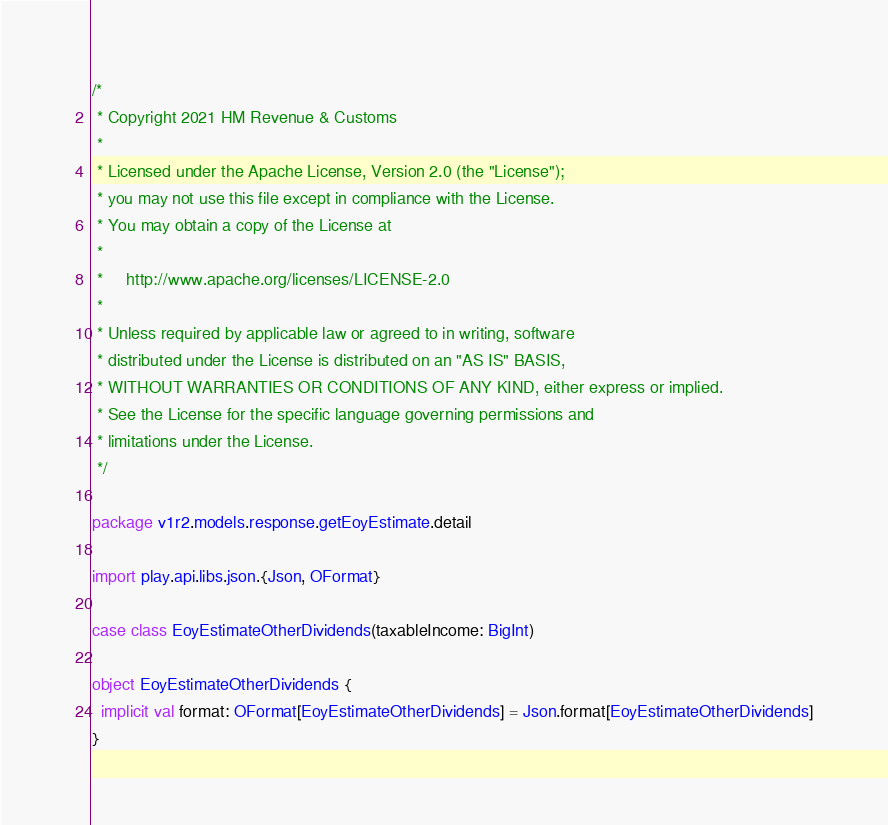<code> <loc_0><loc_0><loc_500><loc_500><_Scala_>/*
 * Copyright 2021 HM Revenue & Customs
 *
 * Licensed under the Apache License, Version 2.0 (the "License");
 * you may not use this file except in compliance with the License.
 * You may obtain a copy of the License at
 *
 *     http://www.apache.org/licenses/LICENSE-2.0
 *
 * Unless required by applicable law or agreed to in writing, software
 * distributed under the License is distributed on an "AS IS" BASIS,
 * WITHOUT WARRANTIES OR CONDITIONS OF ANY KIND, either express or implied.
 * See the License for the specific language governing permissions and
 * limitations under the License.
 */

package v1r2.models.response.getEoyEstimate.detail

import play.api.libs.json.{Json, OFormat}

case class EoyEstimateOtherDividends(taxableIncome: BigInt)

object EoyEstimateOtherDividends {
  implicit val format: OFormat[EoyEstimateOtherDividends] = Json.format[EoyEstimateOtherDividends]
}</code> 